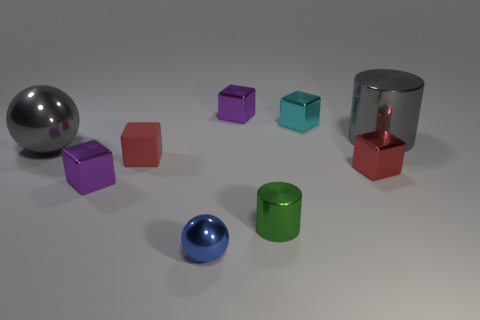Subtract all red blocks. How many blocks are left? 3 Subtract all purple cubes. How many cubes are left? 3 Subtract 1 cubes. How many cubes are left? 4 Subtract all purple blocks. How many red spheres are left? 0 Subtract all blocks. How many objects are left? 4 Subtract all purple balls. Subtract all red cylinders. How many balls are left? 2 Subtract all purple metallic cylinders. Subtract all tiny cyan metallic things. How many objects are left? 8 Add 6 tiny spheres. How many tiny spheres are left? 7 Add 6 purple metal things. How many purple metal things exist? 8 Subtract 1 gray cylinders. How many objects are left? 8 